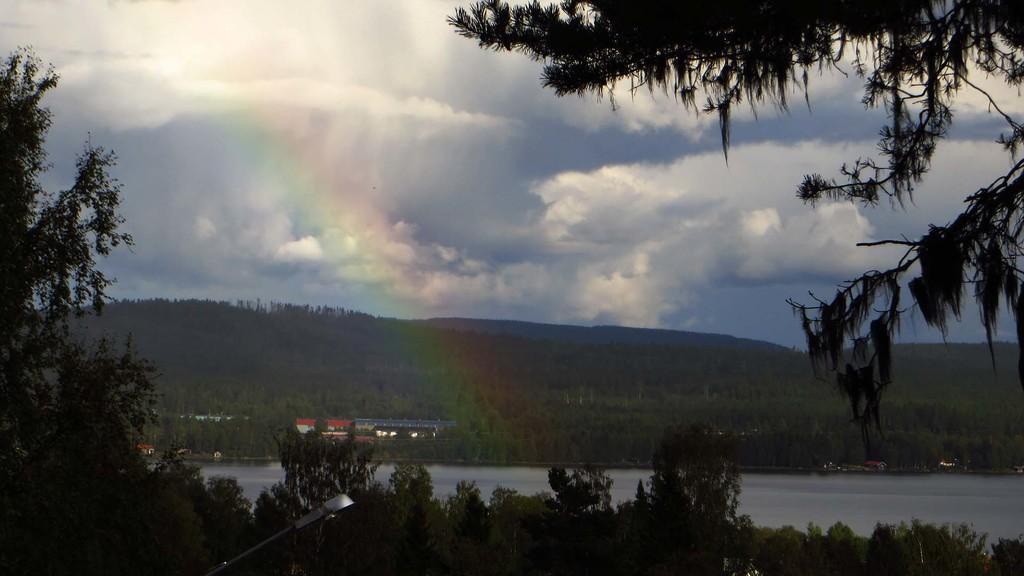Can you describe this image briefly? In this image we can see a lake. There are many trees in the image. There are few houses in the image. There is blue and cloudy sky in the image. 